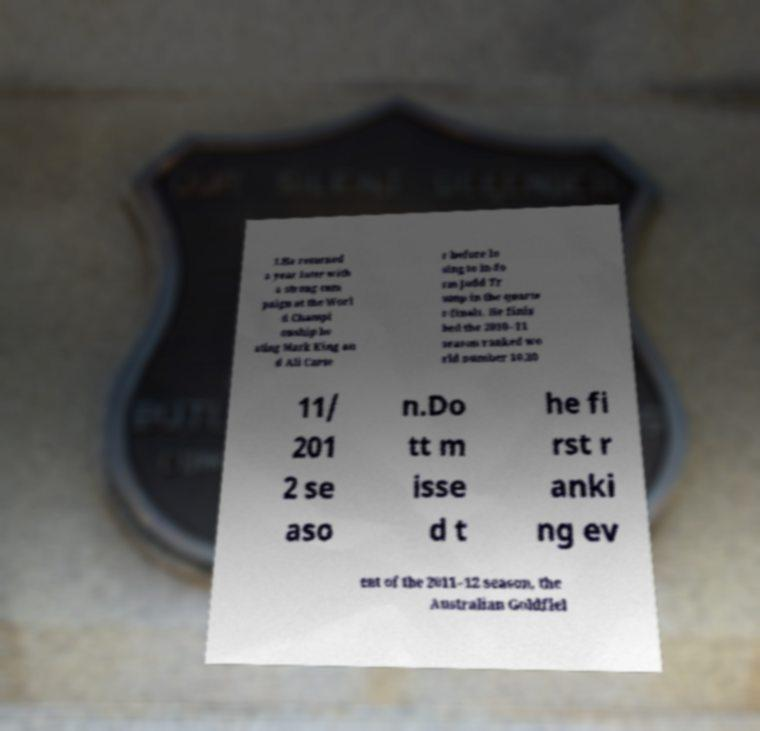Could you assist in decoding the text presented in this image and type it out clearly? 1.He returned a year later with a strong cam paign at the Worl d Champi onship be ating Mark King an d Ali Carte r before lo sing to in-fo rm Judd Tr ump in the quarte r-finals. He finis hed the 2010–11 season ranked wo rld number 10.20 11/ 201 2 se aso n.Do tt m isse d t he fi rst r anki ng ev ent of the 2011–12 season, the Australian Goldfiel 